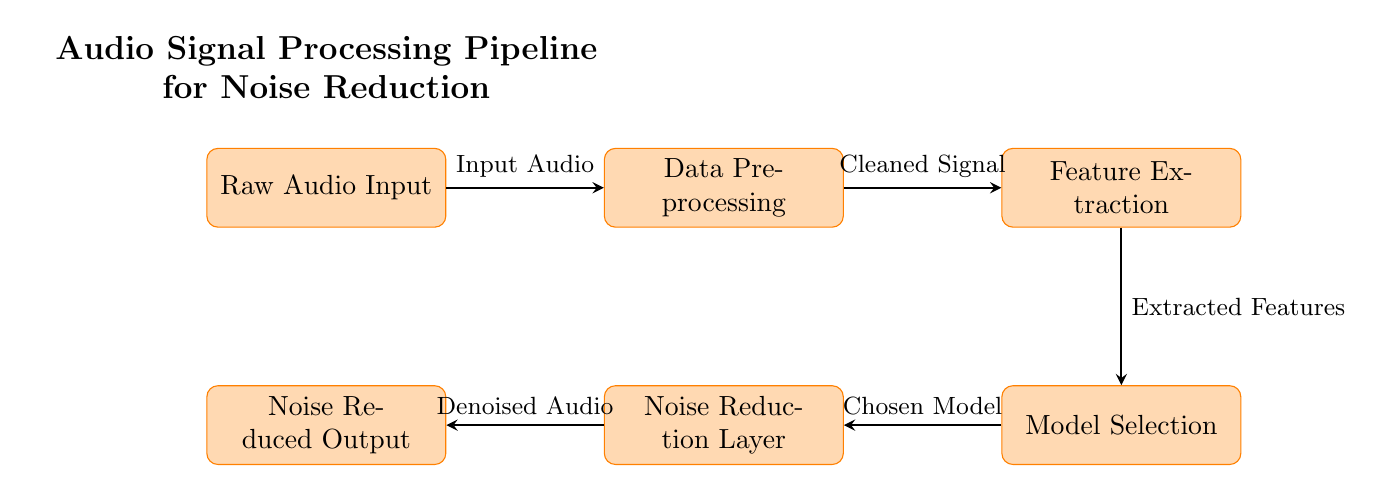What is the first step in the pipeline? The first step in the pipeline is indicated by the leftmost node, which is labeled "Raw Audio Input". This node represents the initial input into the entire audio processing system.
Answer: Raw Audio Input How many nodes are present in the diagram? The number of nodes can be determined by counting each rectangular shape, which represents a process. There are a total of five nodes in the diagram: Raw Audio Input, Data Preprocessing, Feature Extraction, Model Selection, and Noise Reduction Layer.
Answer: Five What does the output of the last node represent? The output from the last node, labeled "Noise Reduced Output", shows the result of the noise reduction process. It signifies the final product of the entire audio signal processing task.
Answer: Noise Reduced Output Which node is directly after Data Preprocessing? By following the arrows that indicate the flow from one process to another, the node directly after Data Preprocessing is labeled "Feature Extraction", indicating the sequence in the audio processing pipeline.
Answer: Feature Extraction What is being transferred from Feature Extraction to Model Selection? The flow from Feature Extraction to Model Selection is represented by an arrow, and the label on this arrow states "Extracted Features". This indicates that the features derived from the audio signal are sent to the model selection phase.
Answer: Extracted Features Which process occurs before the Noise Reduction Layer? The process that occurs immediately before the Noise Reduction Layer is the Model Selection. Following the established directional flow in the diagram, the arrow shows that the chosen model comes from the model selection step.
Answer: Model Selection What type of model is referred to before the Noise Reduction Layer? The model referred to is labeled as "Chosen Model", which is derived from the Model Selection process. This implies that the selection of an appropriate model takes place just before noise reduction begins.
Answer: Chosen Model What does the arrow from Data Preprocessing to Feature Extraction signify? The arrow from Data Preprocessing to Feature Extraction represents the flow of data, and it is labeled "Cleaned Signal", indicating that the output of the preprocessing step is a signal ready for feature extraction.
Answer: Cleaned Signal 